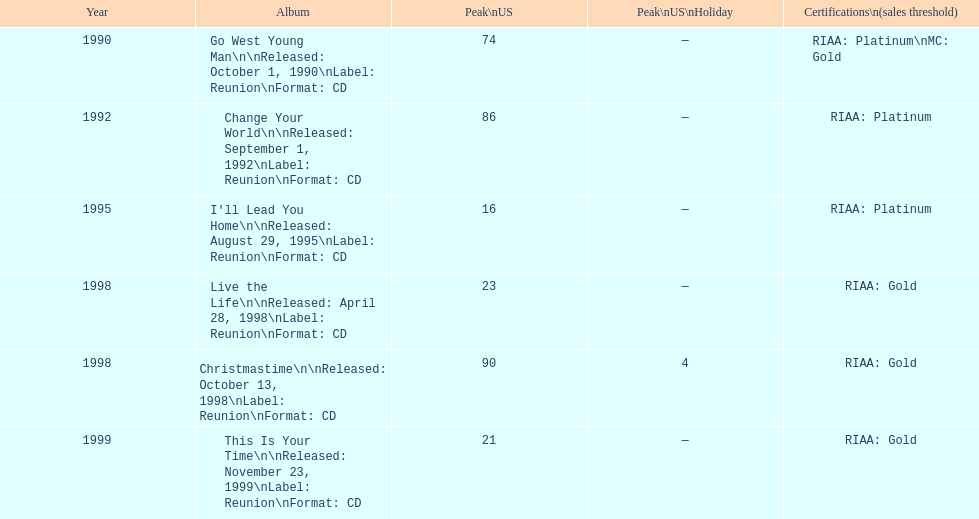How many album entries are there? 6. 